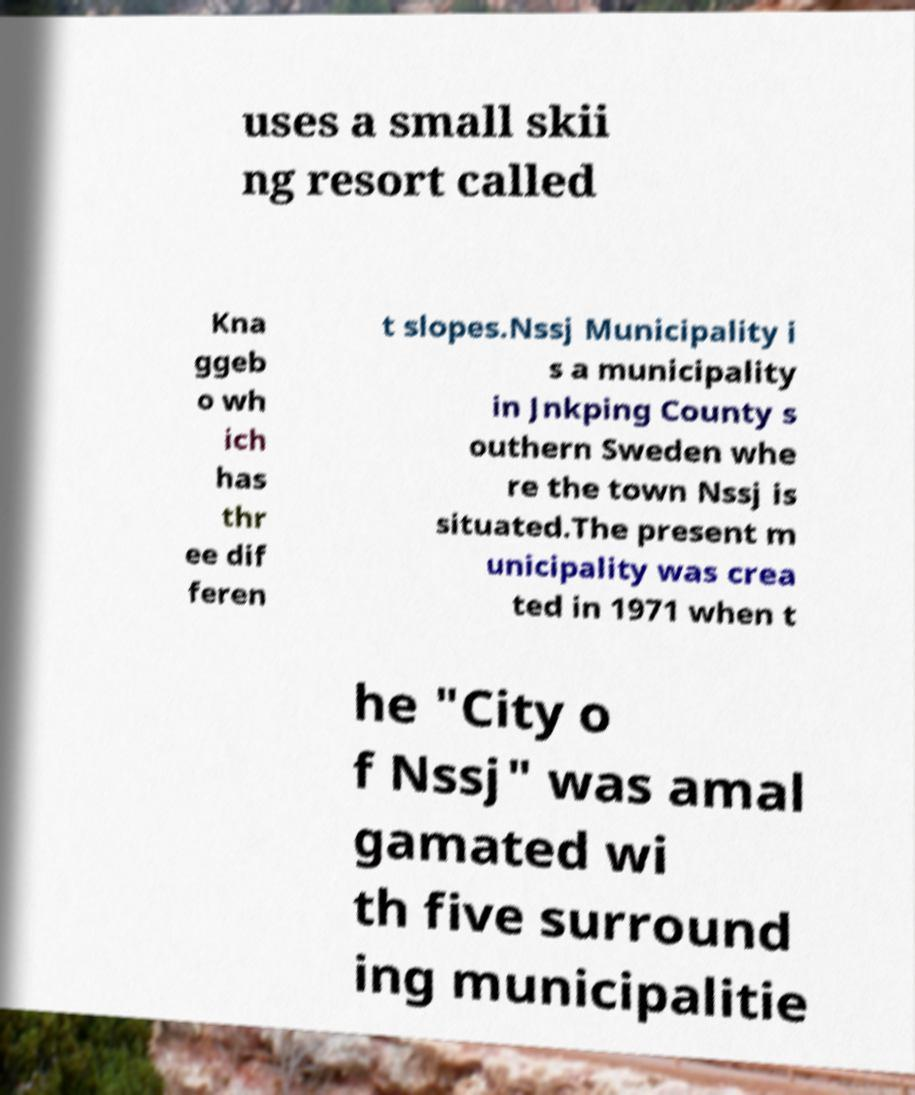There's text embedded in this image that I need extracted. Can you transcribe it verbatim? uses a small skii ng resort called Kna ggeb o wh ich has thr ee dif feren t slopes.Nssj Municipality i s a municipality in Jnkping County s outhern Sweden whe re the town Nssj is situated.The present m unicipality was crea ted in 1971 when t he "City o f Nssj" was amal gamated wi th five surround ing municipalitie 